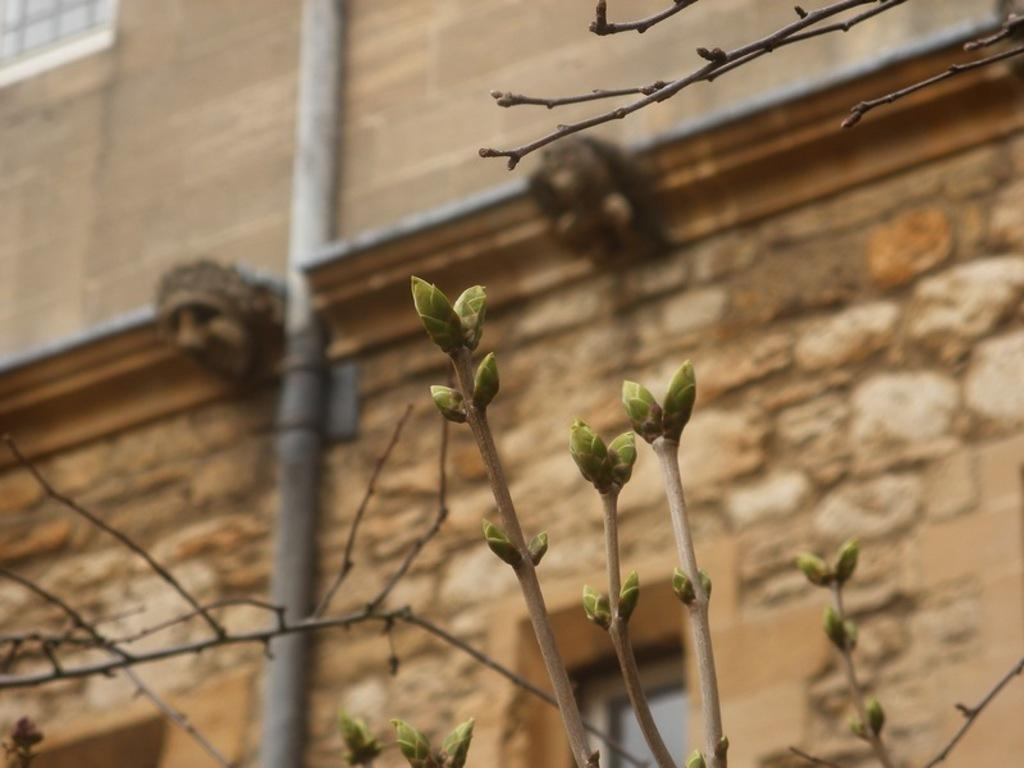What is the main structure visible in the image? There is a building wall in the image. Is there anything attached to the building wall? Yes, there is a pipe attached to the building wall. What type of vegetation is present in the image? There are plants with stems and leaves in the image. What is the weight of the wing visible in the image? There is no wing present in the image; it only features a building wall, a pipe, and plants. 